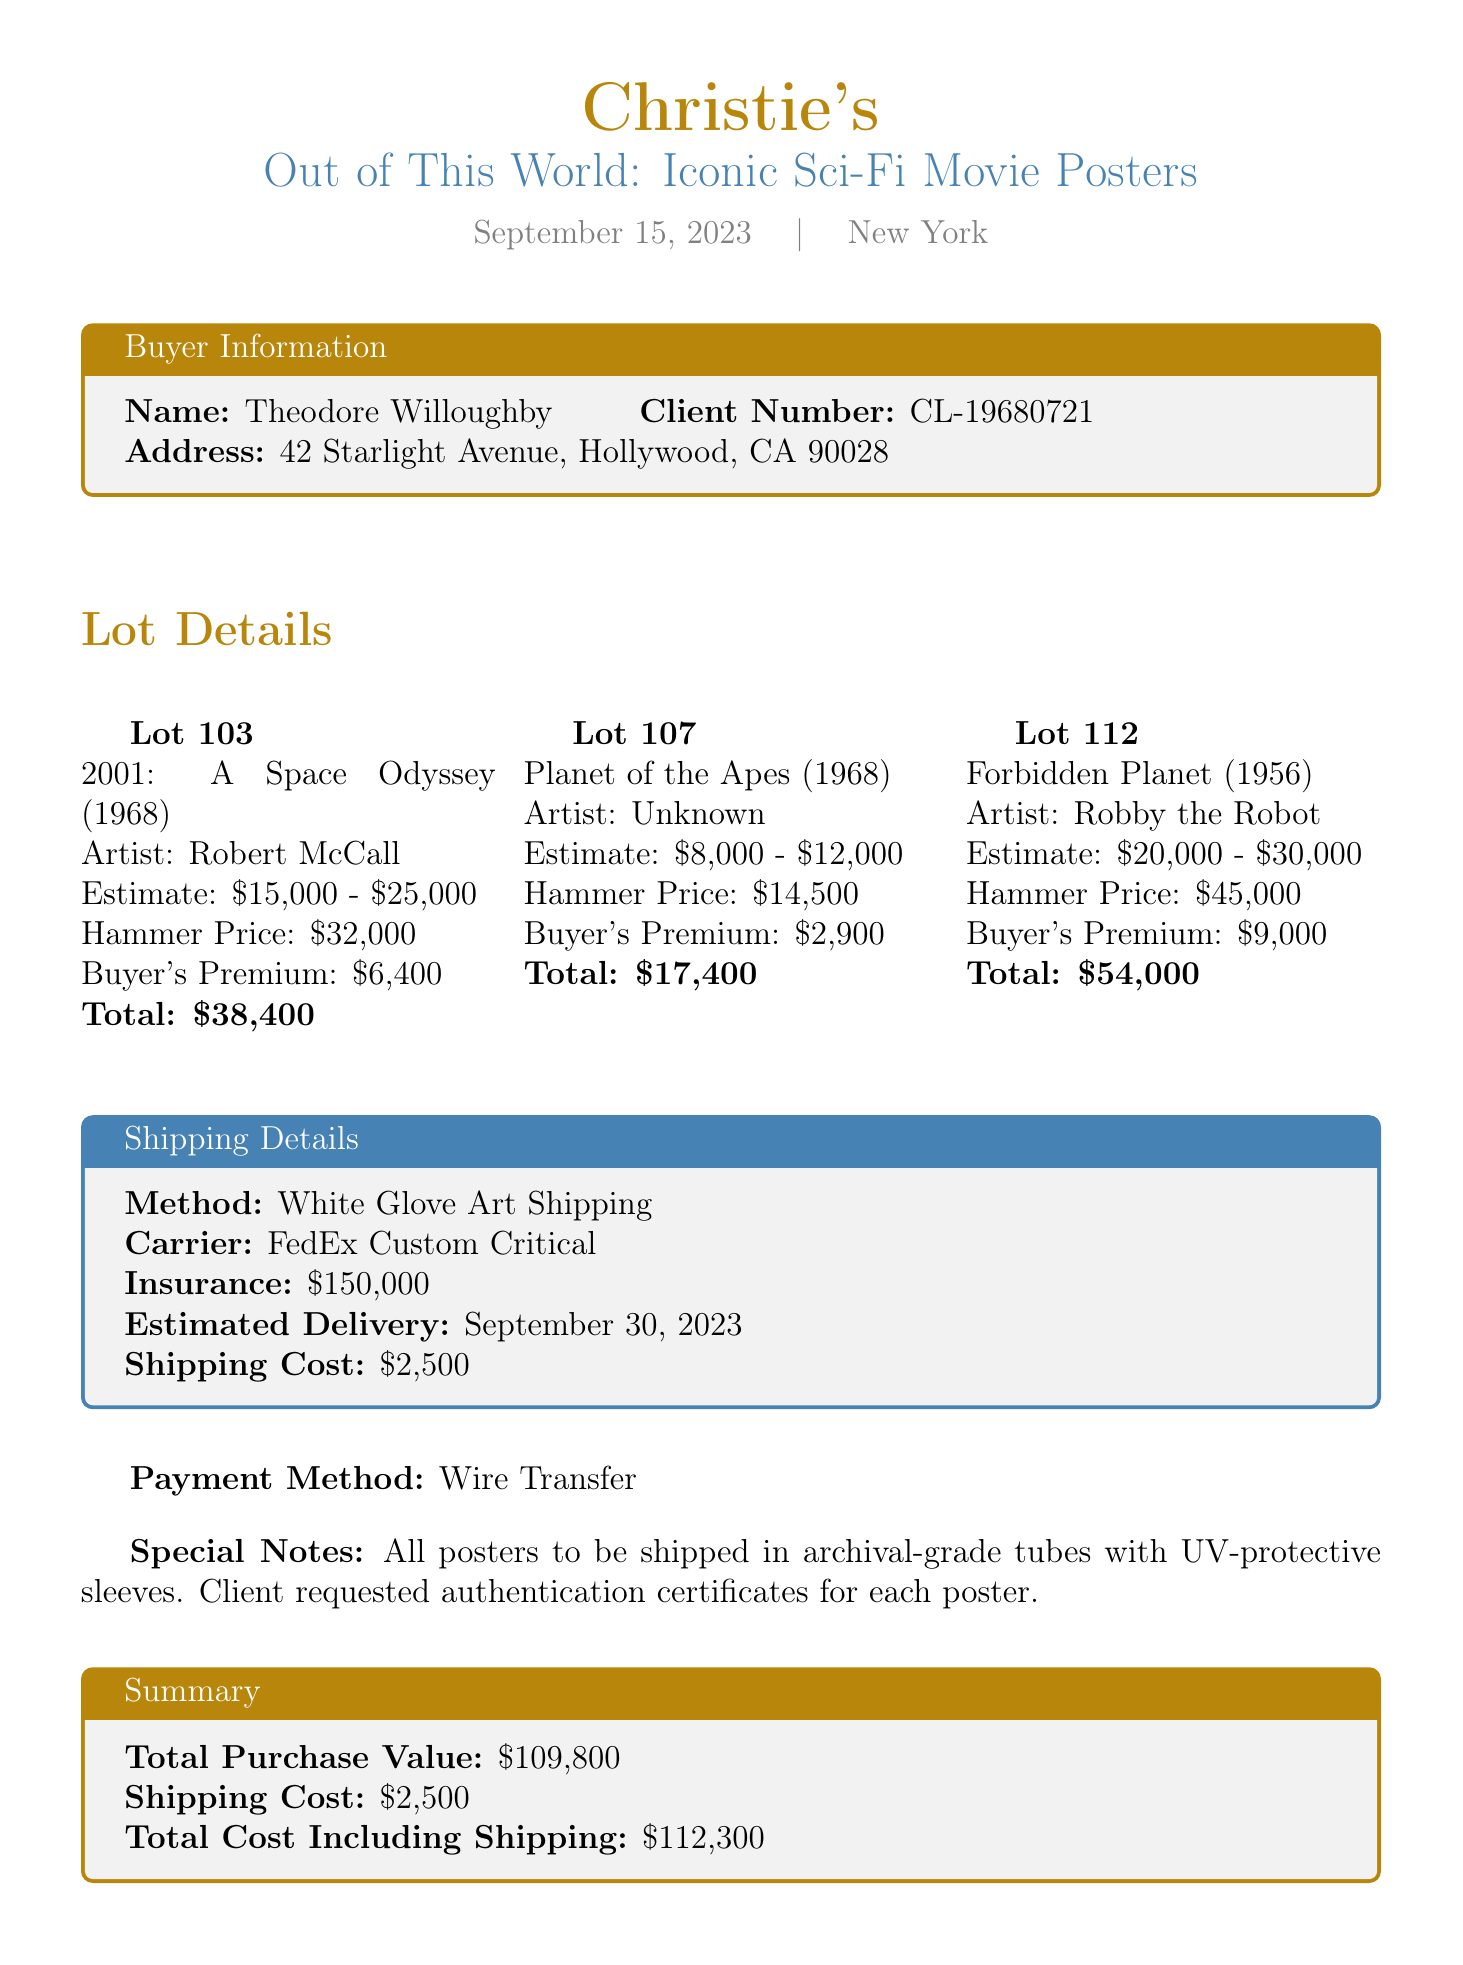What is the auction house name? The auction house name is indicated at the top of the document.
Answer: Christie's What is the title of the sale? The title of the sale can be found in the header information of the document.
Answer: Out of This World: Iconic Sci-Fi Movie Posters What was the hammer price for "2001: A Space Odyssey"? This information is listed under the lot details for that specific poster.
Answer: 32000 Who is the buyer? The buyer's name is found in the buyer information section of the document.
Answer: Theodore Willoughby What is the total purchase value? The total purchase value is calculated based on the individual lot totals.
Answer: 109800 How much is the buyer's premium for "Planet of the Apes"? The buyer's premium is provided for this specific lot in its details.
Answer: 2900 How much did the shipping cost? The shipping cost is detailed in the shipping section of the document.
Answer: 2500 What date is the estimated delivery? The estimated delivery date is listed under the shipping details.
Answer: September 30, 2023 What method is used for shipping? The shipping method is explicitly stated in the shipping details section.
Answer: White Glove Art Shipping 